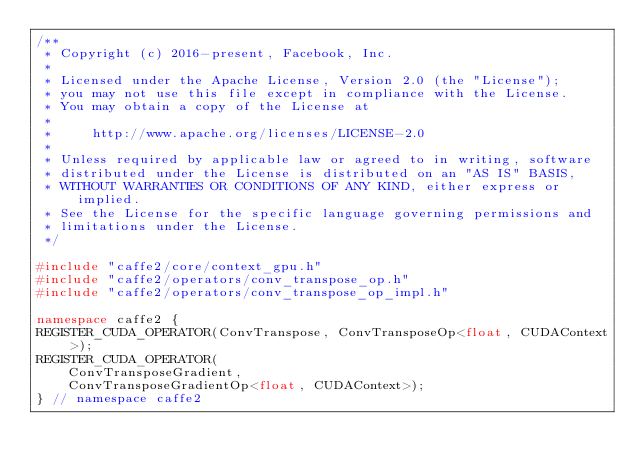<code> <loc_0><loc_0><loc_500><loc_500><_C++_>/**
 * Copyright (c) 2016-present, Facebook, Inc.
 *
 * Licensed under the Apache License, Version 2.0 (the "License");
 * you may not use this file except in compliance with the License.
 * You may obtain a copy of the License at
 *
 *     http://www.apache.org/licenses/LICENSE-2.0
 *
 * Unless required by applicable law or agreed to in writing, software
 * distributed under the License is distributed on an "AS IS" BASIS,
 * WITHOUT WARRANTIES OR CONDITIONS OF ANY KIND, either express or implied.
 * See the License for the specific language governing permissions and
 * limitations under the License.
 */

#include "caffe2/core/context_gpu.h"
#include "caffe2/operators/conv_transpose_op.h"
#include "caffe2/operators/conv_transpose_op_impl.h"

namespace caffe2 {
REGISTER_CUDA_OPERATOR(ConvTranspose, ConvTransposeOp<float, CUDAContext>);
REGISTER_CUDA_OPERATOR(
    ConvTransposeGradient,
    ConvTransposeGradientOp<float, CUDAContext>);
} // namespace caffe2
</code> 